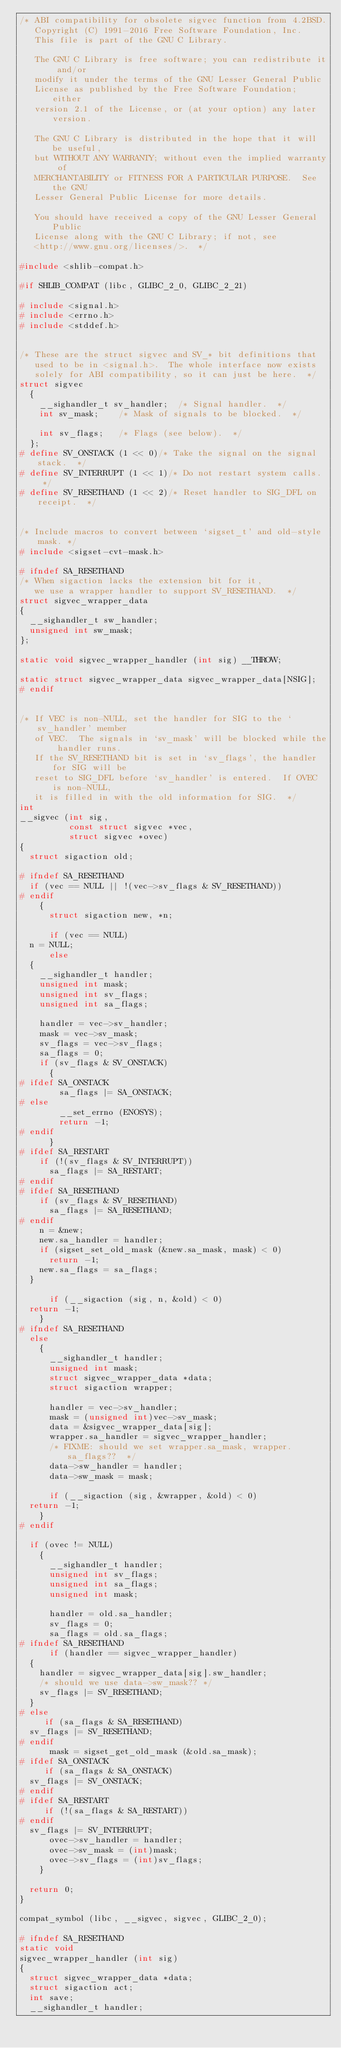<code> <loc_0><loc_0><loc_500><loc_500><_C_>/* ABI compatibility for obsolete sigvec function from 4.2BSD.
   Copyright (C) 1991-2016 Free Software Foundation, Inc.
   This file is part of the GNU C Library.

   The GNU C Library is free software; you can redistribute it and/or
   modify it under the terms of the GNU Lesser General Public
   License as published by the Free Software Foundation; either
   version 2.1 of the License, or (at your option) any later version.

   The GNU C Library is distributed in the hope that it will be useful,
   but WITHOUT ANY WARRANTY; without even the implied warranty of
   MERCHANTABILITY or FITNESS FOR A PARTICULAR PURPOSE.  See the GNU
   Lesser General Public License for more details.

   You should have received a copy of the GNU Lesser General Public
   License along with the GNU C Library; if not, see
   <http://www.gnu.org/licenses/>.  */

#include <shlib-compat.h>

#if SHLIB_COMPAT (libc, GLIBC_2_0, GLIBC_2_21)

# include <signal.h>
# include <errno.h>
# include <stddef.h>


/* These are the struct sigvec and SV_* bit definitions that
   used to be in <signal.h>.  The whole interface now exists
   solely for ABI compatibility, so it can just be here.  */
struct sigvec
  {
    __sighandler_t sv_handler;	/* Signal handler.  */
    int sv_mask;		/* Mask of signals to be blocked.  */

    int sv_flags;		/* Flags (see below).  */
  };
# define SV_ONSTACK	(1 << 0)/* Take the signal on the signal stack.  */
# define SV_INTERRUPT	(1 << 1)/* Do not restart system calls.  */
# define SV_RESETHAND	(1 << 2)/* Reset handler to SIG_DFL on receipt.  */


/* Include macros to convert between `sigset_t' and old-style mask. */
# include <sigset-cvt-mask.h>

# ifndef SA_RESETHAND
/* When sigaction lacks the extension bit for it,
   we use a wrapper handler to support SV_RESETHAND.  */
struct sigvec_wrapper_data
{
  __sighandler_t sw_handler;
  unsigned int sw_mask;
};

static void sigvec_wrapper_handler (int sig) __THROW;

static struct sigvec_wrapper_data sigvec_wrapper_data[NSIG];
# endif


/* If VEC is non-NULL, set the handler for SIG to the `sv_handler' member
   of VEC.  The signals in `sv_mask' will be blocked while the handler runs.
   If the SV_RESETHAND bit is set in `sv_flags', the handler for SIG will be
   reset to SIG_DFL before `sv_handler' is entered.  If OVEC is non-NULL,
   it is filled in with the old information for SIG.  */
int
__sigvec (int sig,
          const struct sigvec *vec,
          struct sigvec *ovec)
{
  struct sigaction old;

# ifndef SA_RESETHAND
  if (vec == NULL || !(vec->sv_flags & SV_RESETHAND))
# endif
    {
      struct sigaction new, *n;

      if (vec == NULL)
	n = NULL;
      else
	{
	  __sighandler_t handler;
	  unsigned int mask;
	  unsigned int sv_flags;
	  unsigned int sa_flags;

	  handler = vec->sv_handler;
	  mask = vec->sv_mask;
	  sv_flags = vec->sv_flags;
	  sa_flags = 0;
	  if (sv_flags & SV_ONSTACK)
	    {
# ifdef SA_ONSTACK
	      sa_flags |= SA_ONSTACK;
# else
	      __set_errno (ENOSYS);
	      return -1;
# endif
	    }
# ifdef SA_RESTART
	  if (!(sv_flags & SV_INTERRUPT))
	    sa_flags |= SA_RESTART;
# endif
# ifdef SA_RESETHAND
	  if (sv_flags & SV_RESETHAND)
	    sa_flags |= SA_RESETHAND;
# endif
	  n = &new;
	  new.sa_handler = handler;
	  if (sigset_set_old_mask (&new.sa_mask, mask) < 0)
	    return -1;
	  new.sa_flags = sa_flags;
	}

      if (__sigaction (sig, n, &old) < 0)
	return -1;
    }
# ifndef SA_RESETHAND
  else
    {
      __sighandler_t handler;
      unsigned int mask;
      struct sigvec_wrapper_data *data;
      struct sigaction wrapper;

      handler = vec->sv_handler;
      mask = (unsigned int)vec->sv_mask;
      data = &sigvec_wrapper_data[sig];
      wrapper.sa_handler = sigvec_wrapper_handler;
      /* FIXME: should we set wrapper.sa_mask, wrapper.sa_flags??  */
      data->sw_handler = handler;
      data->sw_mask = mask;

      if (__sigaction (sig, &wrapper, &old) < 0)
	return -1;
    }
# endif

  if (ovec != NULL)
    {
      __sighandler_t handler;
      unsigned int sv_flags;
      unsigned int sa_flags;
      unsigned int mask;

      handler = old.sa_handler;
      sv_flags = 0;
      sa_flags = old.sa_flags;
# ifndef SA_RESETHAND
      if (handler == sigvec_wrapper_handler)
	{
	  handler = sigvec_wrapper_data[sig].sw_handler;
	  /* should we use data->sw_mask?? */
	  sv_flags |= SV_RESETHAND;
	}
# else
     if (sa_flags & SA_RESETHAND)
	sv_flags |= SV_RESETHAND;
# endif
      mask = sigset_get_old_mask (&old.sa_mask);
# ifdef SA_ONSTACK
     if (sa_flags & SA_ONSTACK)
	sv_flags |= SV_ONSTACK;
# endif
# ifdef SA_RESTART
     if (!(sa_flags & SA_RESTART))
# endif
	sv_flags |= SV_INTERRUPT;
      ovec->sv_handler = handler;
      ovec->sv_mask = (int)mask;
      ovec->sv_flags = (int)sv_flags;
    }

  return 0;
}

compat_symbol (libc, __sigvec, sigvec, GLIBC_2_0);

# ifndef SA_RESETHAND
static void
sigvec_wrapper_handler (int sig)
{
  struct sigvec_wrapper_data *data;
  struct sigaction act;
  int save;
  __sighandler_t handler;
</code> 